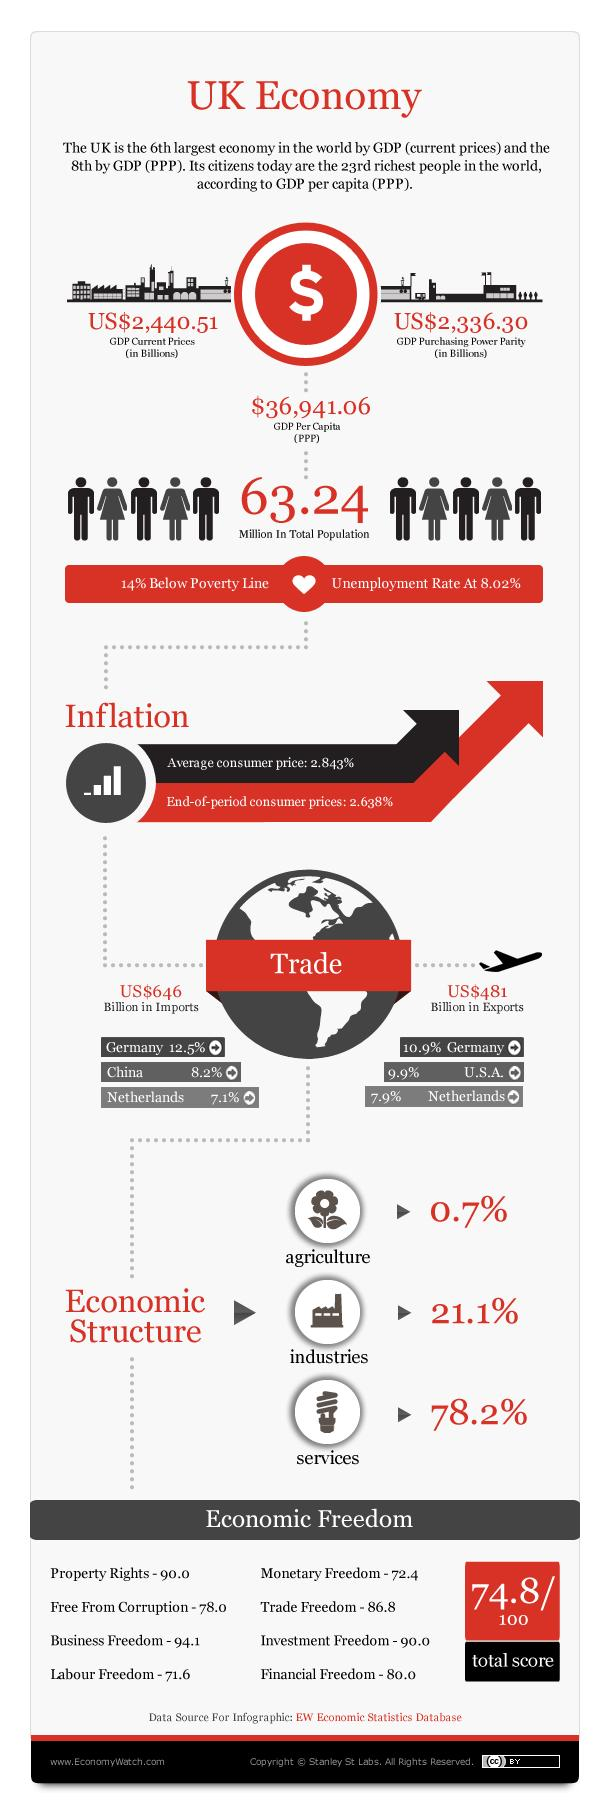Indicate a few pertinent items in this graphic. Ninety-nine percent of UK exports are sent to the United States, The GDP purchasing power parity in the United Kingdom is approximately $2,336.30 billion. The value of UK exports was approximately 481 billion US dollars in 2021. The sector that contributes the most to the UK's Gross Domestic Product (GDP) is services. The United Kingdom imports a significant percentage of its goods from the Netherlands, with a total of 7.1% of its imports coming from that country. 